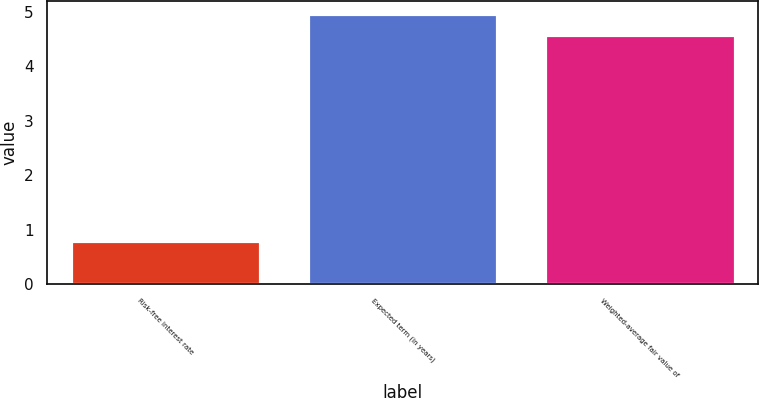<chart> <loc_0><loc_0><loc_500><loc_500><bar_chart><fcel>Risk-free interest rate<fcel>Expected term (in years)<fcel>Weighted-average fair value of<nl><fcel>0.79<fcel>4.95<fcel>4.57<nl></chart> 